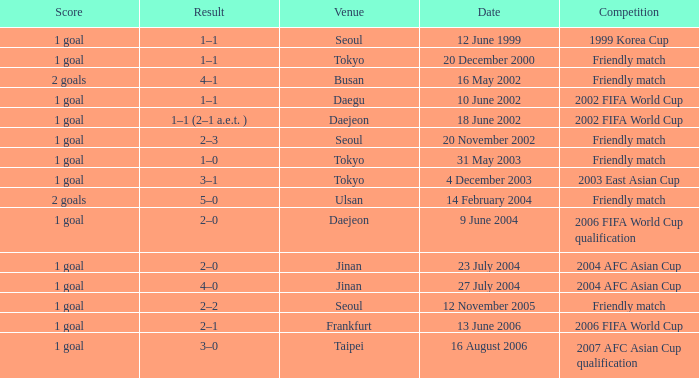Could you parse the entire table as a dict? {'header': ['Score', 'Result', 'Venue', 'Date', 'Competition'], 'rows': [['1 goal', '1–1', 'Seoul', '12 June 1999', '1999 Korea Cup'], ['1 goal', '1–1', 'Tokyo', '20 December 2000', 'Friendly match'], ['2 goals', '4–1', 'Busan', '16 May 2002', 'Friendly match'], ['1 goal', '1–1', 'Daegu', '10 June 2002', '2002 FIFA World Cup'], ['1 goal', '1–1 (2–1 a.e.t. )', 'Daejeon', '18 June 2002', '2002 FIFA World Cup'], ['1 goal', '2–3', 'Seoul', '20 November 2002', 'Friendly match'], ['1 goal', '1–0', 'Tokyo', '31 May 2003', 'Friendly match'], ['1 goal', '3–1', 'Tokyo', '4 December 2003', '2003 East Asian Cup'], ['2 goals', '5–0', 'Ulsan', '14 February 2004', 'Friendly match'], ['1 goal', '2–0', 'Daejeon', '9 June 2004', '2006 FIFA World Cup qualification'], ['1 goal', '2–0', 'Jinan', '23 July 2004', '2004 AFC Asian Cup'], ['1 goal', '4–0', 'Jinan', '27 July 2004', '2004 AFC Asian Cup'], ['1 goal', '2–2', 'Seoul', '12 November 2005', 'Friendly match'], ['1 goal', '2–1', 'Frankfurt', '13 June 2006', '2006 FIFA World Cup'], ['1 goal', '3–0', 'Taipei', '16 August 2006', '2007 AFC Asian Cup qualification']]} What is the venue for the event on 12 November 2005? Seoul. 